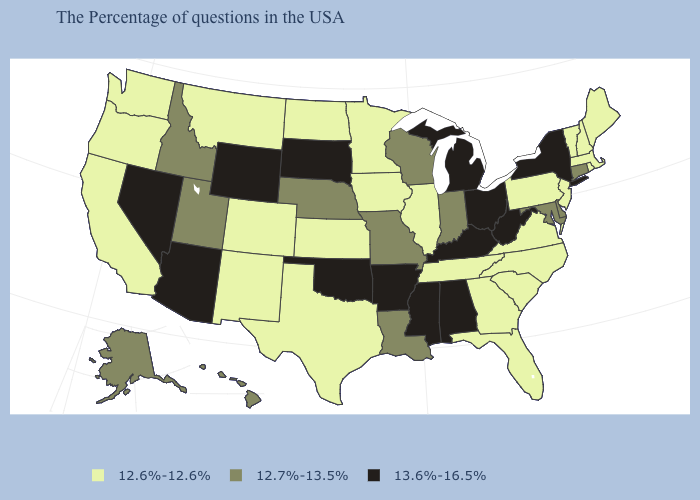Name the states that have a value in the range 13.6%-16.5%?
Quick response, please. New York, West Virginia, Ohio, Michigan, Kentucky, Alabama, Mississippi, Arkansas, Oklahoma, South Dakota, Wyoming, Arizona, Nevada. What is the highest value in states that border Ohio?
Give a very brief answer. 13.6%-16.5%. What is the lowest value in the USA?
Concise answer only. 12.6%-12.6%. Is the legend a continuous bar?
Concise answer only. No. What is the value of Rhode Island?
Keep it brief. 12.6%-12.6%. Name the states that have a value in the range 12.7%-13.5%?
Give a very brief answer. Connecticut, Delaware, Maryland, Indiana, Wisconsin, Louisiana, Missouri, Nebraska, Utah, Idaho, Alaska, Hawaii. What is the lowest value in the MidWest?
Keep it brief. 12.6%-12.6%. Among the states that border Connecticut , which have the lowest value?
Be succinct. Massachusetts, Rhode Island. What is the value of Massachusetts?
Short answer required. 12.6%-12.6%. Name the states that have a value in the range 12.7%-13.5%?
Quick response, please. Connecticut, Delaware, Maryland, Indiana, Wisconsin, Louisiana, Missouri, Nebraska, Utah, Idaho, Alaska, Hawaii. How many symbols are there in the legend?
Give a very brief answer. 3. Which states have the highest value in the USA?
Answer briefly. New York, West Virginia, Ohio, Michigan, Kentucky, Alabama, Mississippi, Arkansas, Oklahoma, South Dakota, Wyoming, Arizona, Nevada. What is the lowest value in states that border Nebraska?
Quick response, please. 12.6%-12.6%. How many symbols are there in the legend?
Concise answer only. 3. Does the first symbol in the legend represent the smallest category?
Quick response, please. Yes. 